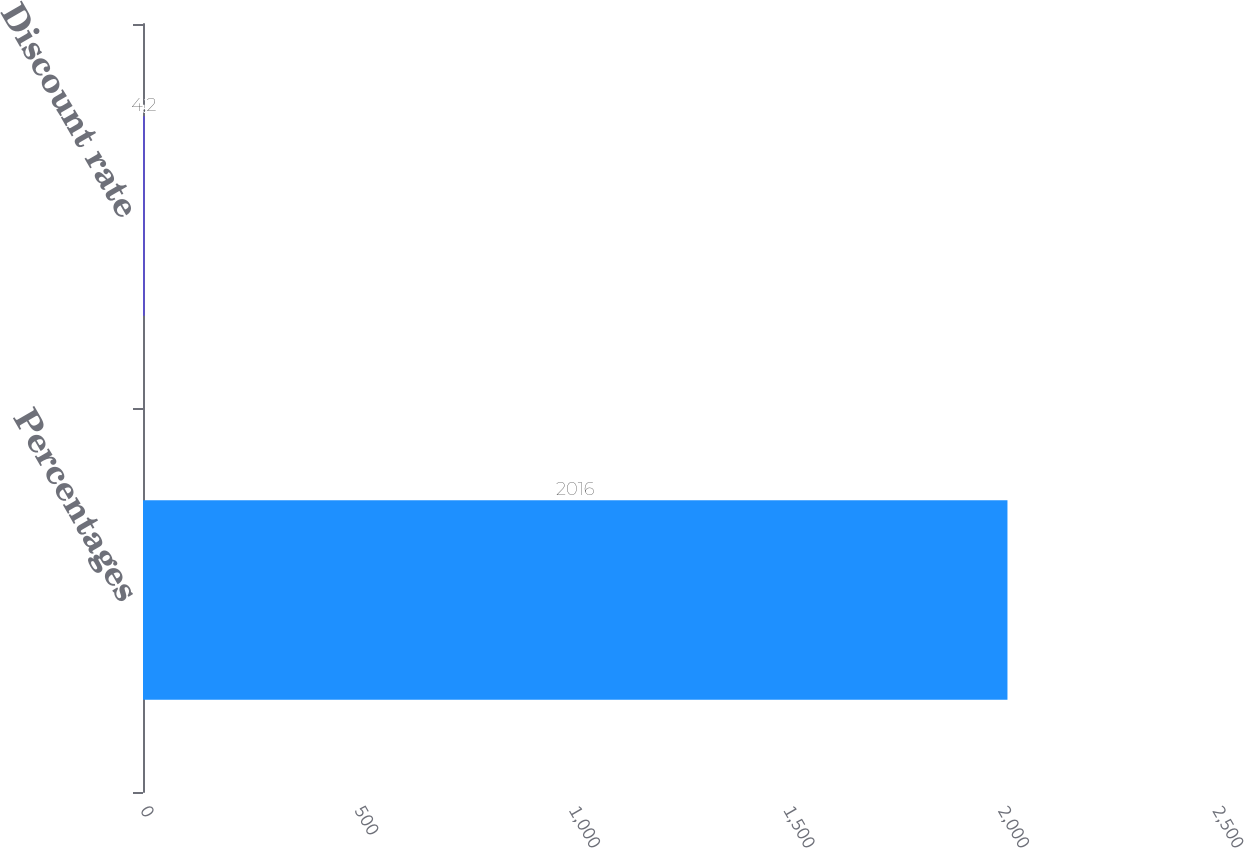Convert chart to OTSL. <chart><loc_0><loc_0><loc_500><loc_500><bar_chart><fcel>Percentages<fcel>Discount rate<nl><fcel>2016<fcel>4.2<nl></chart> 